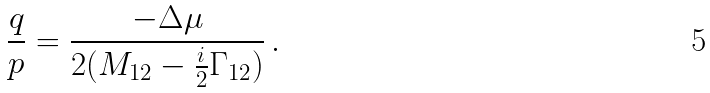<formula> <loc_0><loc_0><loc_500><loc_500>\frac { q } { p } = \frac { - \Delta \mu } { 2 ( M _ { 1 2 } - \frac { i } { 2 } \Gamma _ { 1 2 } ) } \, .</formula> 